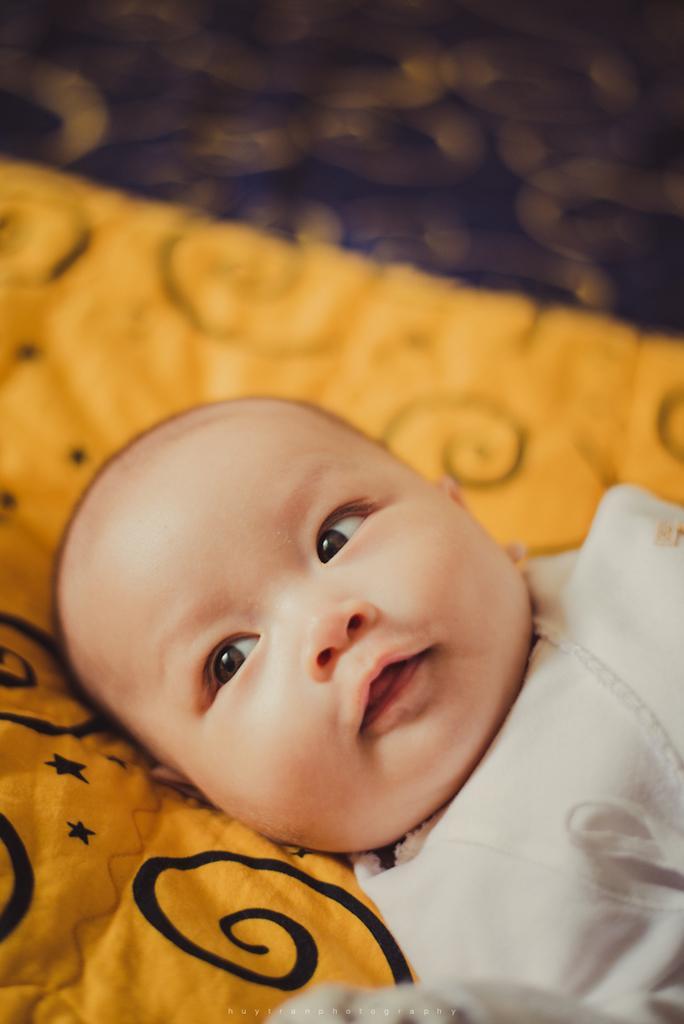How would you summarize this image in a sentence or two? In this image I can see the baby and the baby is laying on the yellow color blanket. The baby is wearing white color dress. 